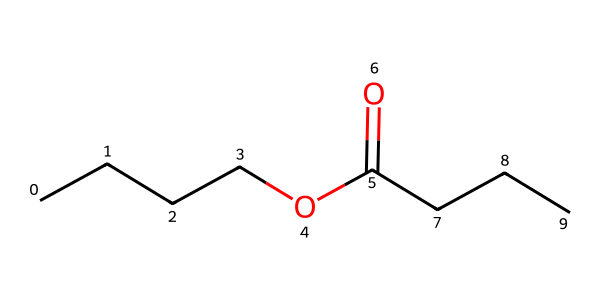What is the molecular formula of butyl butyrate? The SMILES representation reveals that butyl butyrate consists of 7 carbon atoms, 14 hydrogen atoms, and 2 oxygen atoms. Thus, the molecular formula is C7H14O2.
Answer: C7H14O2 How many carbon atoms are present in butyl butyrate? By analyzing the SMILES structure, we count a total of 7 carbon atoms present in the backbone of the compound.
Answer: 7 What type of functional group is present in butyl butyrate? The presence of the carbonyl group (C=O) and the ether linkage (C-O) in the structure indicates that it contains an ester functional group.
Answer: ester What type of bond connects the carbonyl carbon to the oxygen in the ester? The bond connecting the carbonyl carbon to the oxygen is a single bond (C–O bond), indicating the ester linkage characteristic of such compounds.
Answer: single bond Is butyl butyrate a saturated or unsaturated ester? The structure contains only single bonds between carbon atoms and no double bonds, indicating that it is a saturated ester.
Answer: saturated What is the significance of the butyl group in butyl butyrate? The butyl group contributes to the overall structure and flavor profile of the ester, providing the fruity aroma and taste that is characteristic of butyl butyrate.
Answer: fruity aroma 